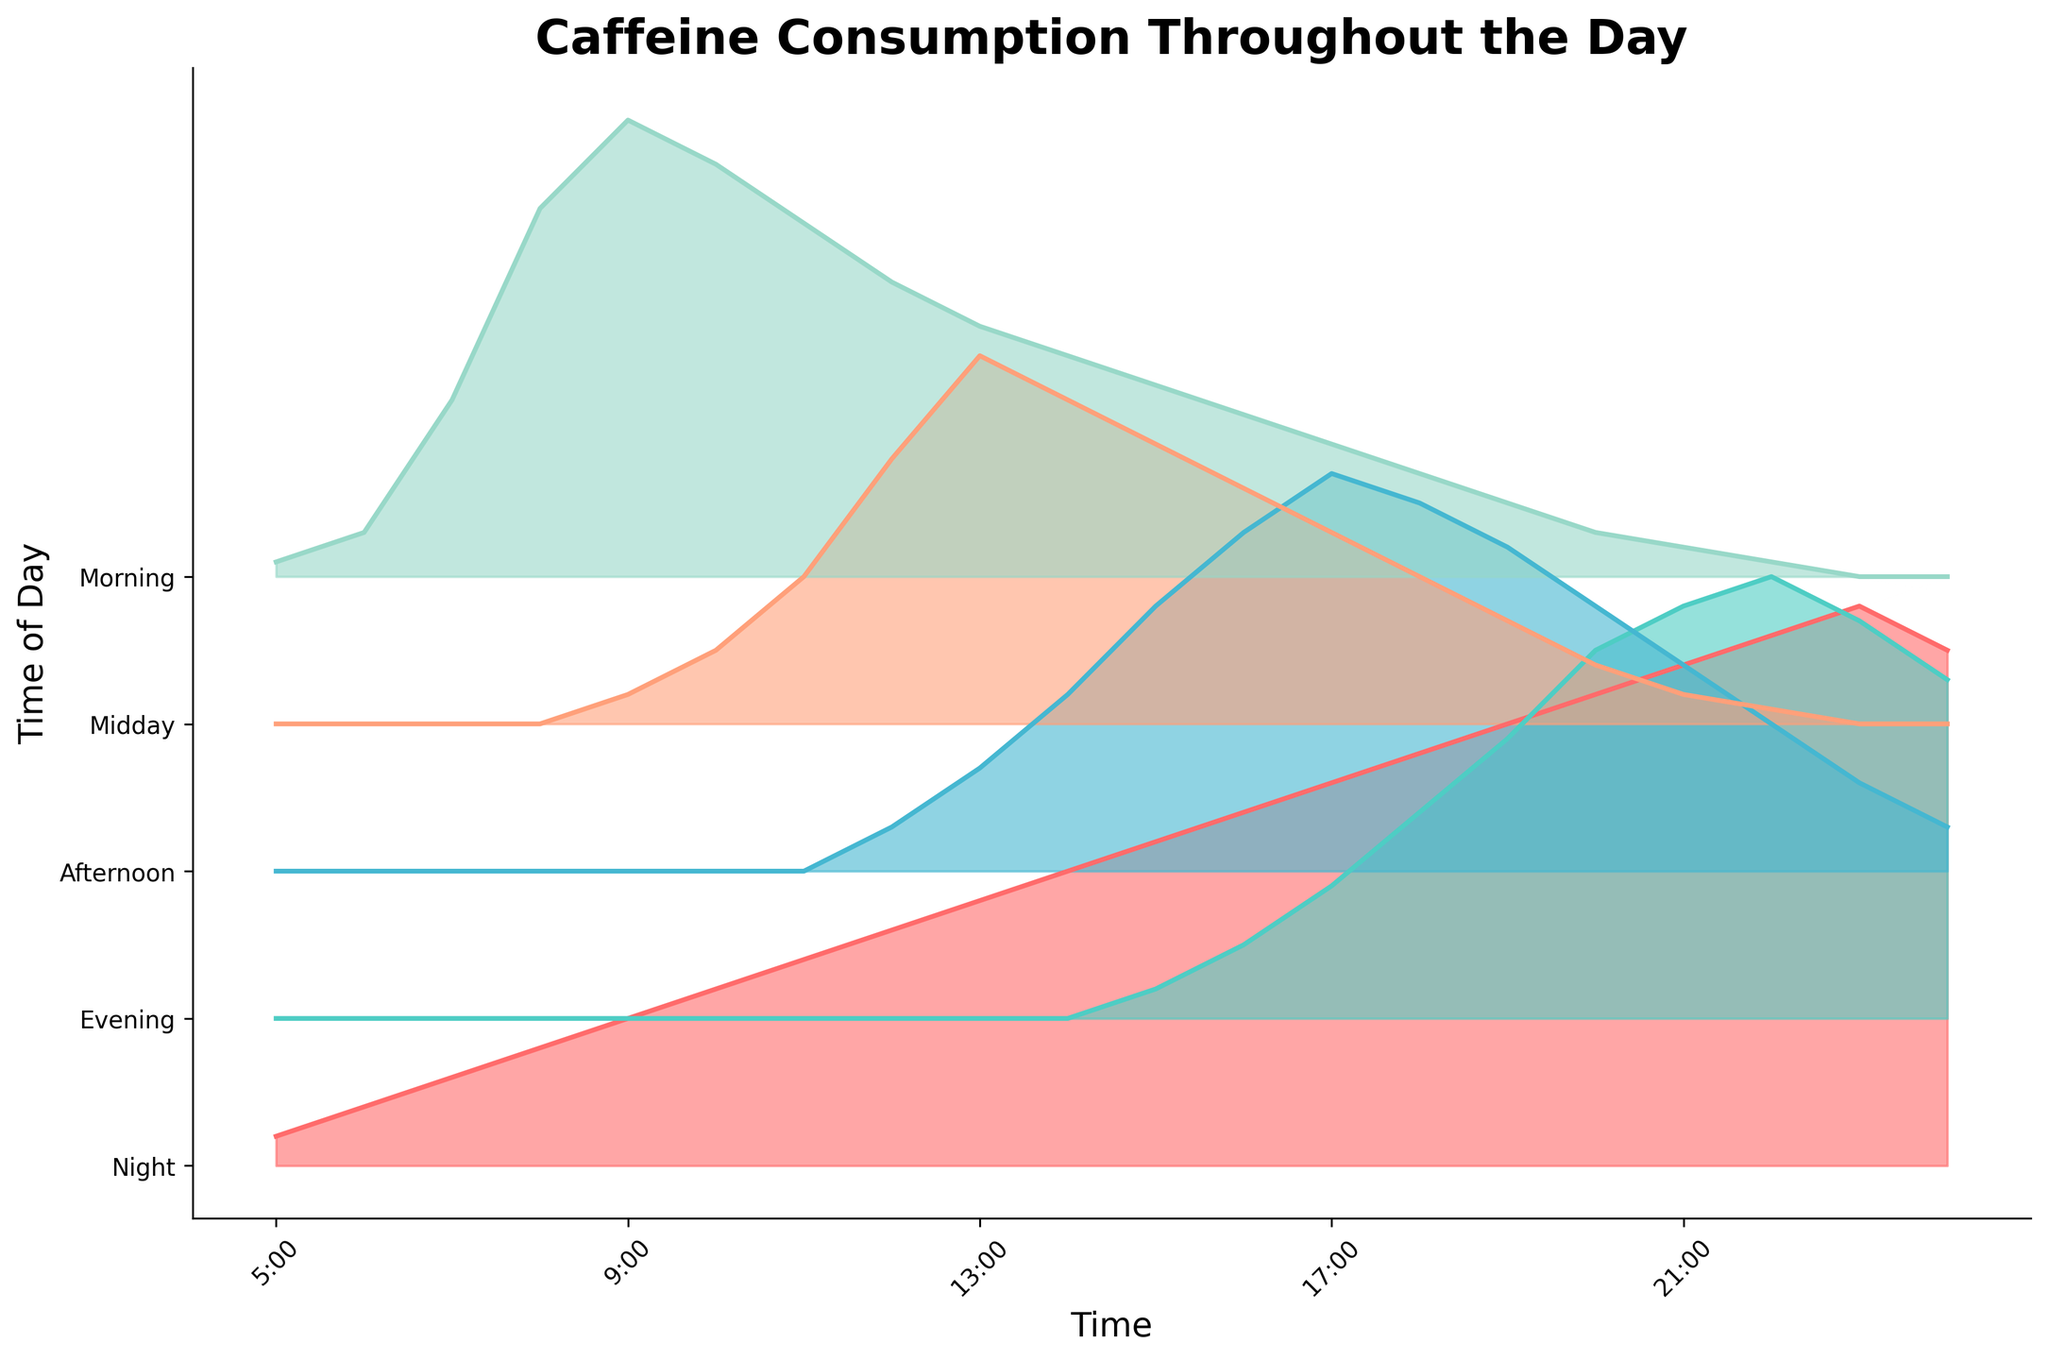What is the title of the plot? The title of the plot is clearly visible at the top of the figure.
Answer: Caffeine Consumption Throughout the Day Which category has the highest caffeine consumption around 20:00? Around 20:00, the height of the colored area for each category can be compared. The 'Night' category has the highest peak.
Answer: Night What times of the day are shown on the x-axis? The x-axis ticks correspond to time intervals shown in the plot, which label specific hours of the day. By checking every 4th tick label, the times are observable.
Answer: 5:00, 9:00, 13:00, 17:00, 21:00 Compare the caffeine consumption between Morning and Midday at 15:00. Which is greater? To compare, look at the heights of Morning and Midday at the 15:00 time point. The Midday line is higher than the Morning line.
Answer: Midday At what time does caffeine consumption peak in the Afternoon category? To find the peak time for Afternoon, observe where the Afternoon line reaches its highest value on the x-axis. This occurs around 17:00.
Answer: 17:00 How does Morning caffeine consumption change from 10:00 to 11:00? Look at the line for Morning between 10:00 and 11:00. The height decreases from 2.8 to 2.4.
Answer: Decreases Identify the category with the smallest caffeine consumption at 7:00. At 7:00, examine the heights of all categories. The Midday, Afternoon, and Evening categories show zero, making them all smallest.
Answer: Midday, Afternoon, Evening Which category generally increases its caffeine consumption trend towards the night? Observe the overall trend of each category. The 'Night' category shows an increasing trend towards the right of the plot.
Answer: Night Calculate the average caffeine consumption for the Night category from 21:00 to 23:00. Sum the caffeine consumption values at 21:00 (3.4), 22:00 (3.6), and 23:00 (3.8). Then, divide by the number of data points, which is 3. The average is (3.4 + 3.6 + 3.8) / 3 = 10.8 / 3.
Answer: 3.6 